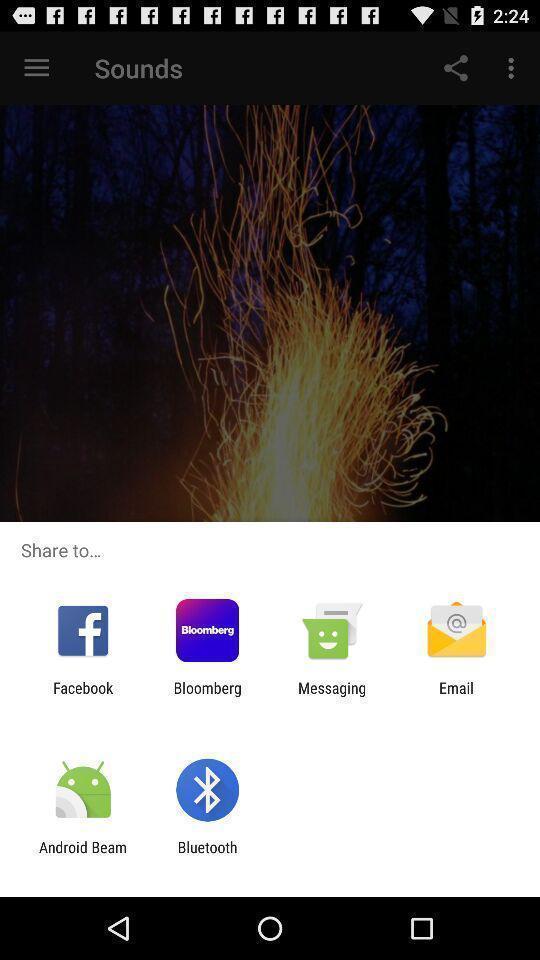Summarize the information in this screenshot. Screen displaying about sharing via different apps. 